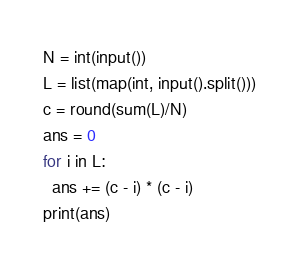Convert code to text. <code><loc_0><loc_0><loc_500><loc_500><_Python_>N = int(input()) 
L = list(map(int, input().split()))
c = round(sum(L)/N)
ans = 0
for i in L:
  ans += (c - i) * (c - i)
print(ans)</code> 